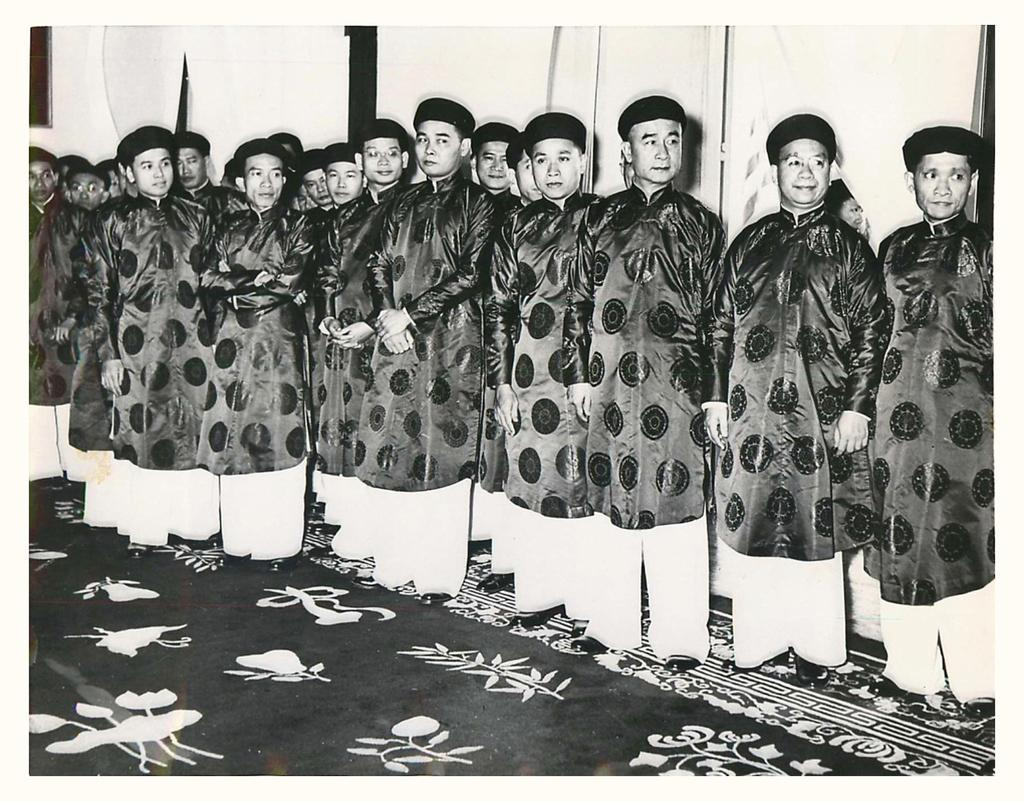What is the main subject of the image? The main subject of the image is a group of people. How are the people in the group dressed? The people in the group are wearing different color dresses and caps. What can be seen in the background of the image? There is a frame on the wall in the background of the image. What is the color scheme of the image? The image is black and white. What type of crime is being committed in the image? There is no indication of a crime being committed in the image; it features a group of people wearing different color dresses and caps. What is the profit margin of the event in the image? There is no indication of an event or profit margin in the image; it simply shows a group of people. 